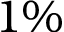<formula> <loc_0><loc_0><loc_500><loc_500>1 \%</formula> 